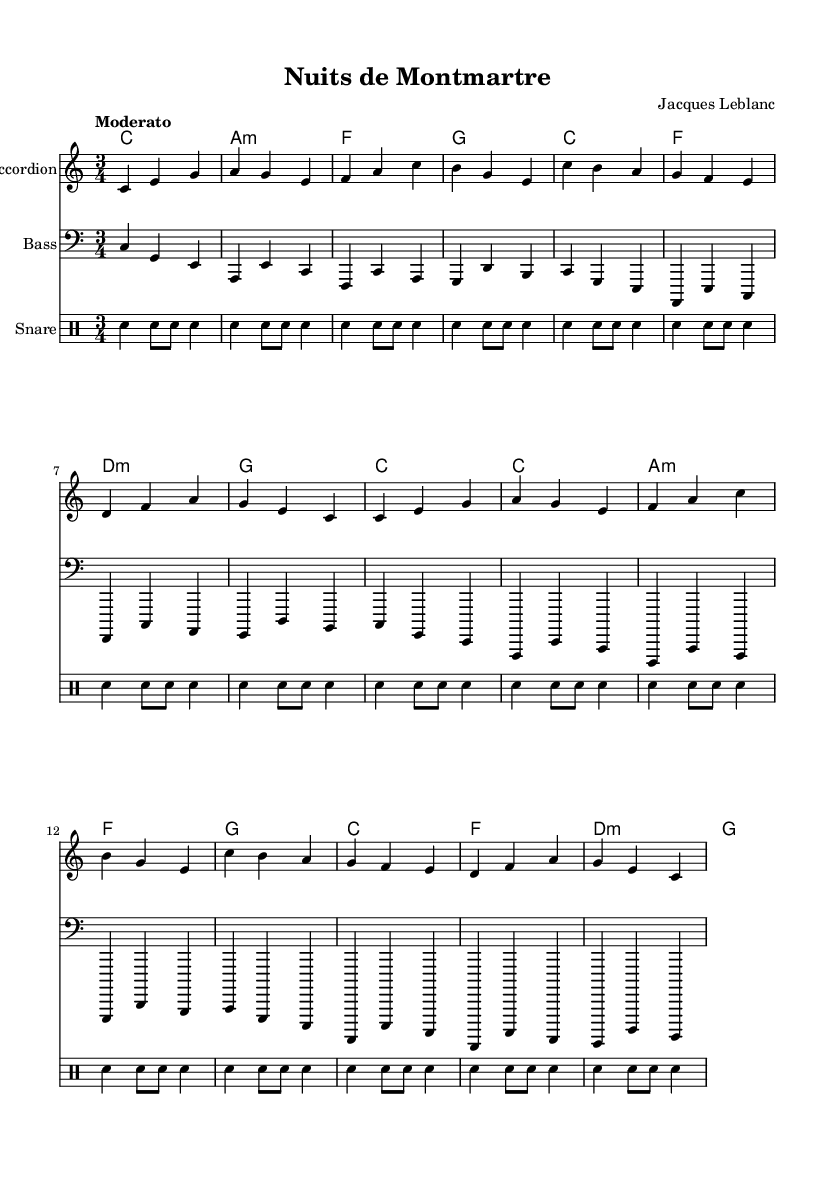What is the key signature of this music? The key signature indicated in the music is C major, as it shows no sharps or flats in the beginning. This is evident from the global settings in the code provided, which clearly specify the key.
Answer: C major What is the time signature of this music? The time signature is 3/4, indicated in the global settings of the music sheet. This means there are three beats in a measure, and each beat is represented by a quarter note.
Answer: 3/4 What is the tempo marking of this composition? The tempo marking is "Moderato," which indicates a moderate pace for the music. This is explicitly written in the global settings of the code, typically reflecting the intended speed for the performance.
Answer: Moderato How many sections are there in the music? There are two main sections labeled as A and B in the provided data. The A section appears twice, with B providing a contrasting theme between them. This structure is a common feature in dance music, allowing for repetition and variation.
Answer: 2 What instruments are included in this score? The instruments indicated in the score are Accordion, Bass, and Snare Drum. Each instrument is listed separately in the score layout, reflecting different musical roles within the composition.
Answer: Accordion, Bass, Snare Drum What is the chord progression in the A section? The chord progression in the A section follows: C, A minor, F, G, D minor, and back to C. This is derived from analyzing the chord mode provided in the code, which outlines how chords are stacked for each section of the music.
Answer: C, A minor, F, G 